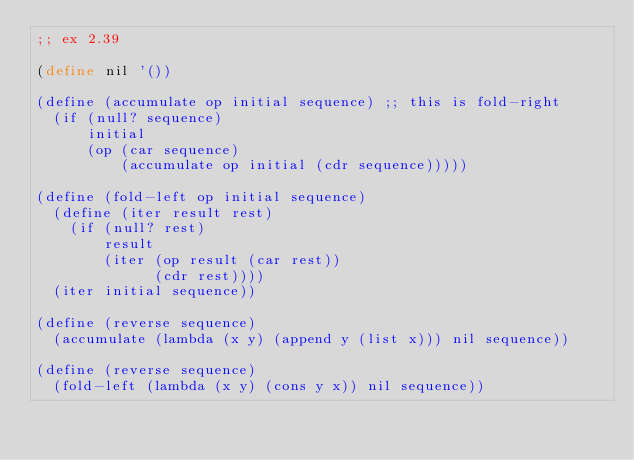Convert code to text. <code><loc_0><loc_0><loc_500><loc_500><_Scheme_>;; ex 2.39

(define nil '())

(define (accumulate op initial sequence) ;; this is fold-right
  (if (null? sequence)
      initial
      (op (car sequence)
          (accumulate op initial (cdr sequence)))))

(define (fold-left op initial sequence)
  (define (iter result rest)
    (if (null? rest)
        result
        (iter (op result (car rest))
              (cdr rest))))
  (iter initial sequence))

(define (reverse sequence)
  (accumulate (lambda (x y) (append y (list x))) nil sequence))

(define (reverse sequence)
  (fold-left (lambda (x y) (cons y x)) nil sequence))
</code> 